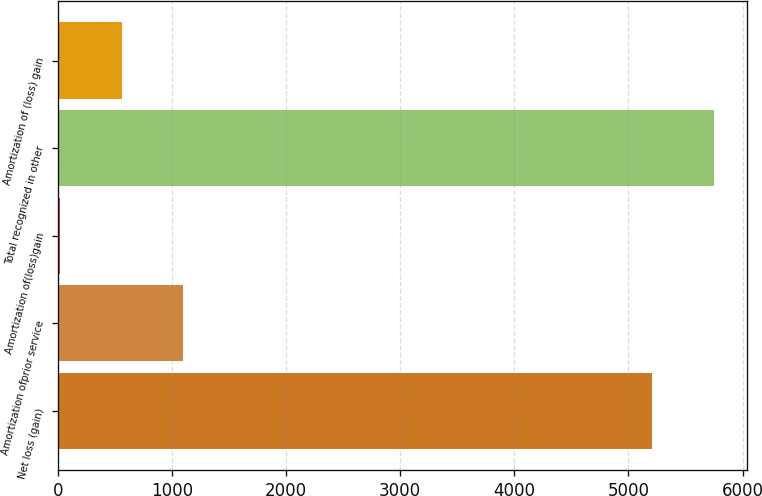<chart> <loc_0><loc_0><loc_500><loc_500><bar_chart><fcel>Net loss (gain)<fcel>Amortization ofprior service<fcel>Amortization of(loss)gain<fcel>Total recognized in other<fcel>Amortization of (loss) gain<nl><fcel>5209<fcel>1101.6<fcel>19<fcel>5750.3<fcel>560.3<nl></chart> 